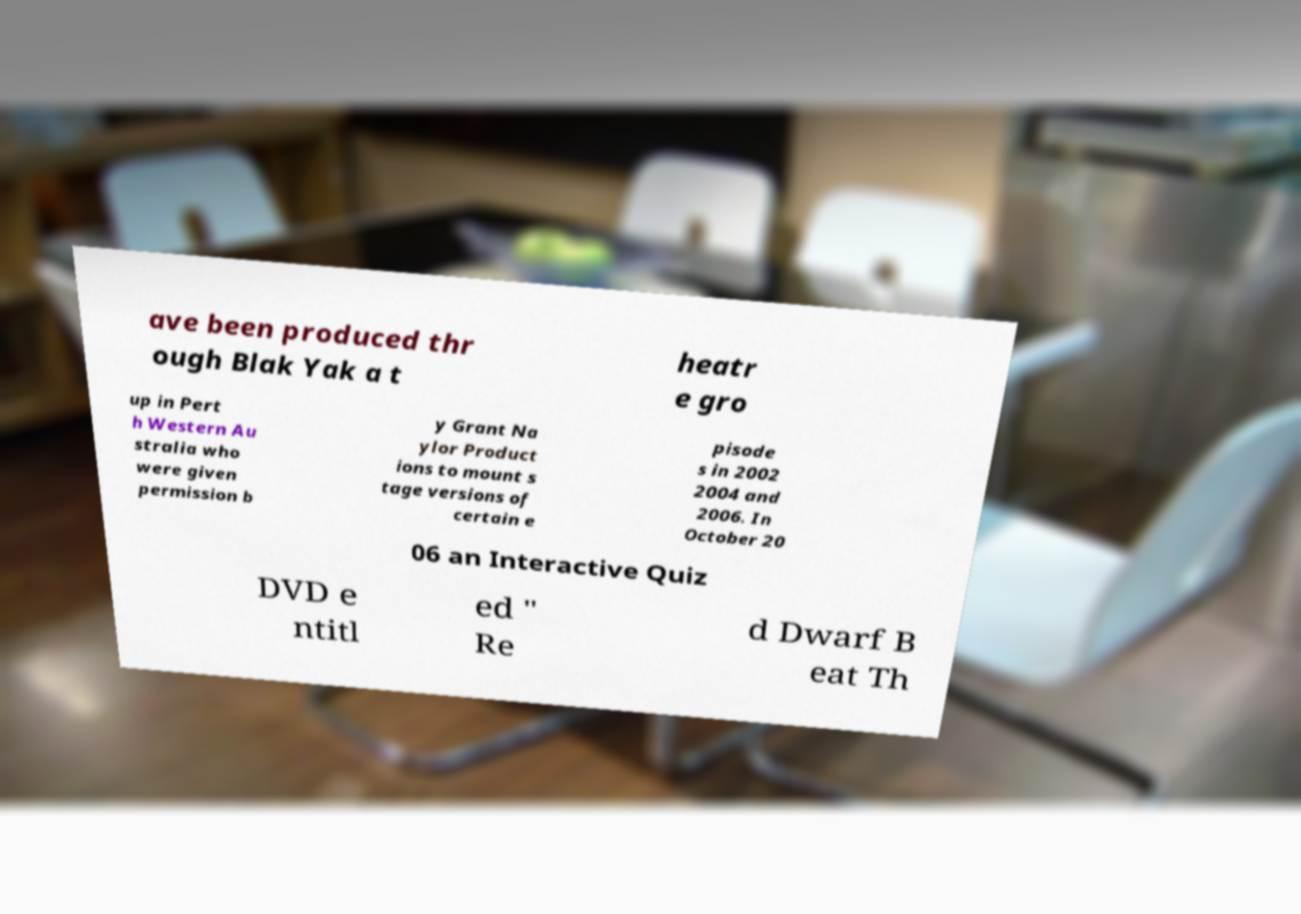There's text embedded in this image that I need extracted. Can you transcribe it verbatim? ave been produced thr ough Blak Yak a t heatr e gro up in Pert h Western Au stralia who were given permission b y Grant Na ylor Product ions to mount s tage versions of certain e pisode s in 2002 2004 and 2006. In October 20 06 an Interactive Quiz DVD e ntitl ed " Re d Dwarf B eat Th 